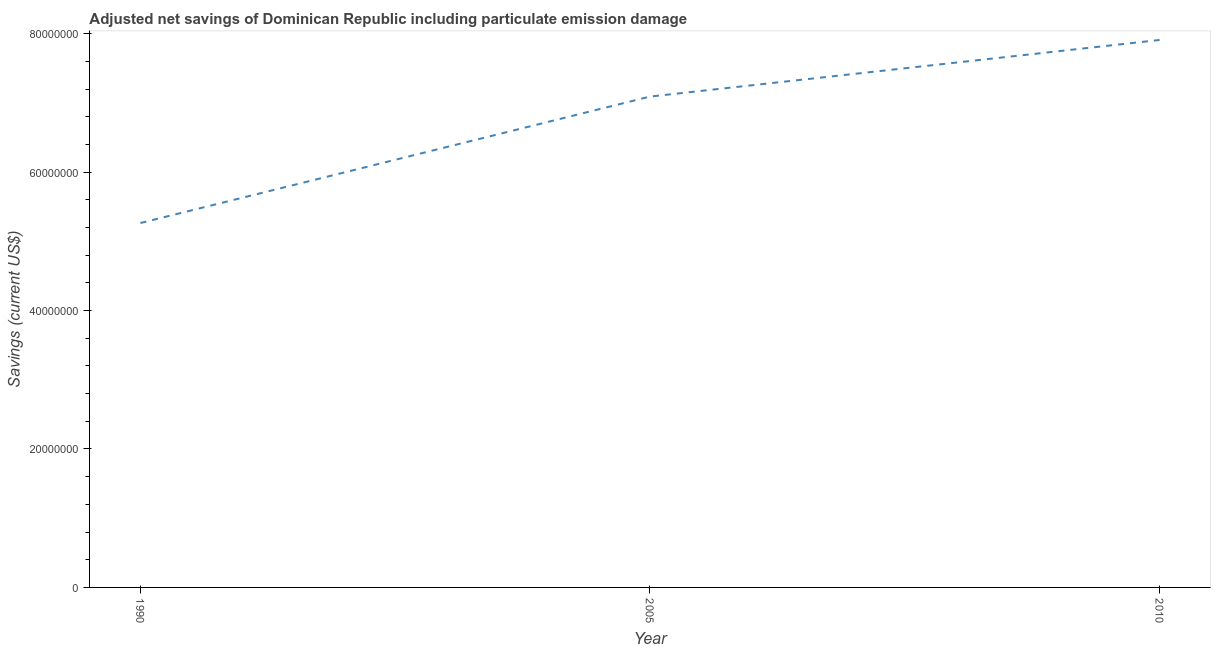What is the adjusted net savings in 2010?
Provide a short and direct response. 7.91e+07. Across all years, what is the maximum adjusted net savings?
Provide a succinct answer. 7.91e+07. Across all years, what is the minimum adjusted net savings?
Provide a succinct answer. 5.26e+07. In which year was the adjusted net savings minimum?
Your answer should be very brief. 1990. What is the sum of the adjusted net savings?
Provide a succinct answer. 2.03e+08. What is the difference between the adjusted net savings in 1990 and 2010?
Keep it short and to the point. -2.64e+07. What is the average adjusted net savings per year?
Keep it short and to the point. 6.75e+07. What is the median adjusted net savings?
Provide a short and direct response. 7.09e+07. Do a majority of the years between 2010 and 2005 (inclusive) have adjusted net savings greater than 28000000 US$?
Keep it short and to the point. No. What is the ratio of the adjusted net savings in 1990 to that in 2005?
Ensure brevity in your answer.  0.74. What is the difference between the highest and the second highest adjusted net savings?
Your response must be concise. 8.18e+06. What is the difference between the highest and the lowest adjusted net savings?
Offer a very short reply. 2.64e+07. Does the adjusted net savings monotonically increase over the years?
Give a very brief answer. Yes. How many lines are there?
Make the answer very short. 1. How many years are there in the graph?
Provide a short and direct response. 3. What is the title of the graph?
Your response must be concise. Adjusted net savings of Dominican Republic including particulate emission damage. What is the label or title of the Y-axis?
Keep it short and to the point. Savings (current US$). What is the Savings (current US$) in 1990?
Your answer should be compact. 5.26e+07. What is the Savings (current US$) of 2005?
Offer a terse response. 7.09e+07. What is the Savings (current US$) in 2010?
Your response must be concise. 7.91e+07. What is the difference between the Savings (current US$) in 1990 and 2005?
Give a very brief answer. -1.83e+07. What is the difference between the Savings (current US$) in 1990 and 2010?
Ensure brevity in your answer.  -2.64e+07. What is the difference between the Savings (current US$) in 2005 and 2010?
Offer a very short reply. -8.18e+06. What is the ratio of the Savings (current US$) in 1990 to that in 2005?
Your answer should be very brief. 0.74. What is the ratio of the Savings (current US$) in 1990 to that in 2010?
Provide a succinct answer. 0.67. What is the ratio of the Savings (current US$) in 2005 to that in 2010?
Your answer should be compact. 0.9. 